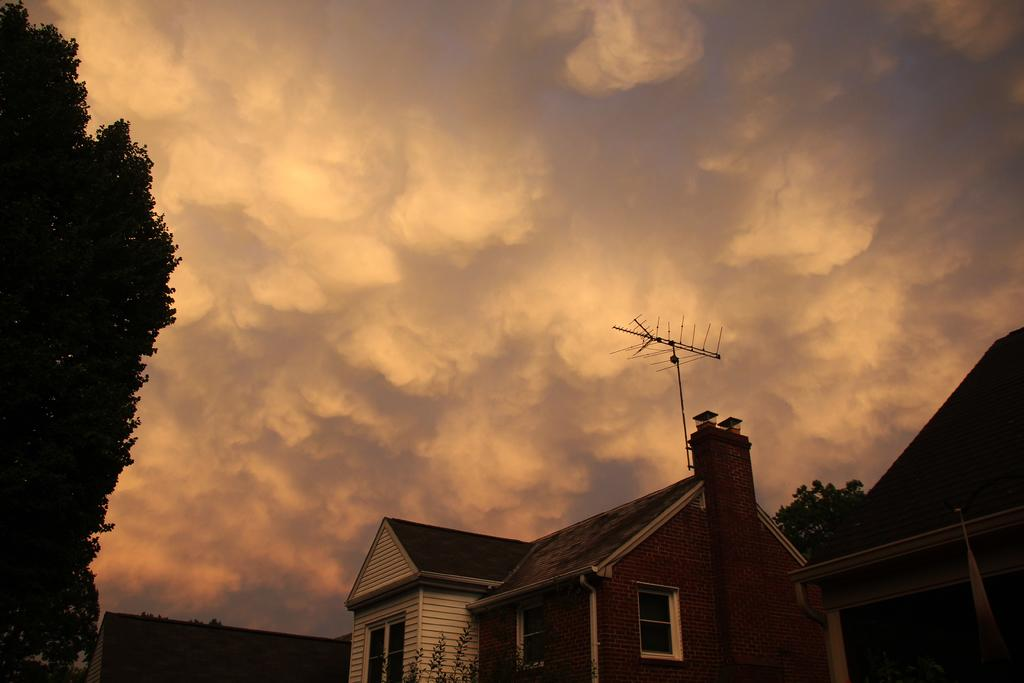What can be seen in the sky in the image? The sky is visible in the image, and there are clouds present. What type of natural elements can be seen in the image? There are trees in the image. What type of man-made structures are present in the image? There are buildings and antennas in the image. What type of knife can be seen cutting through the clouds in the image? There is no knife present in the image, and the clouds are not being cut. 